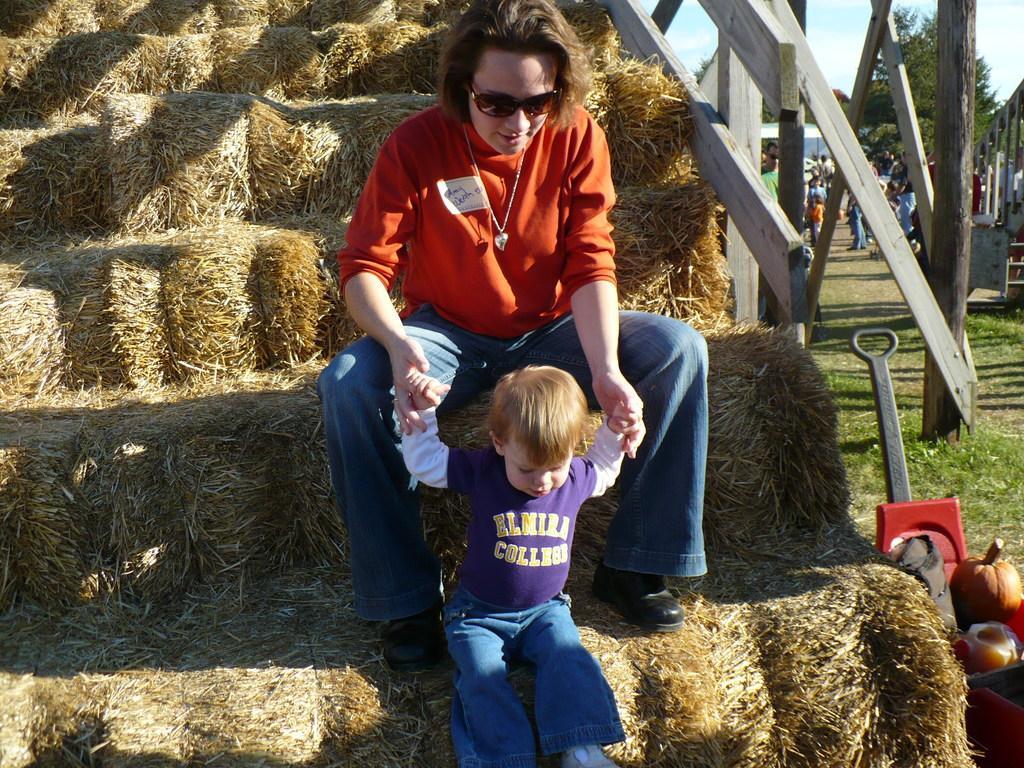Can you describe this image briefly? In this picture, we can see few persons, stairs covered by an object, railing, ground covered with grass, trees, and some objects in the right corner and we can see the sky with clouds. 